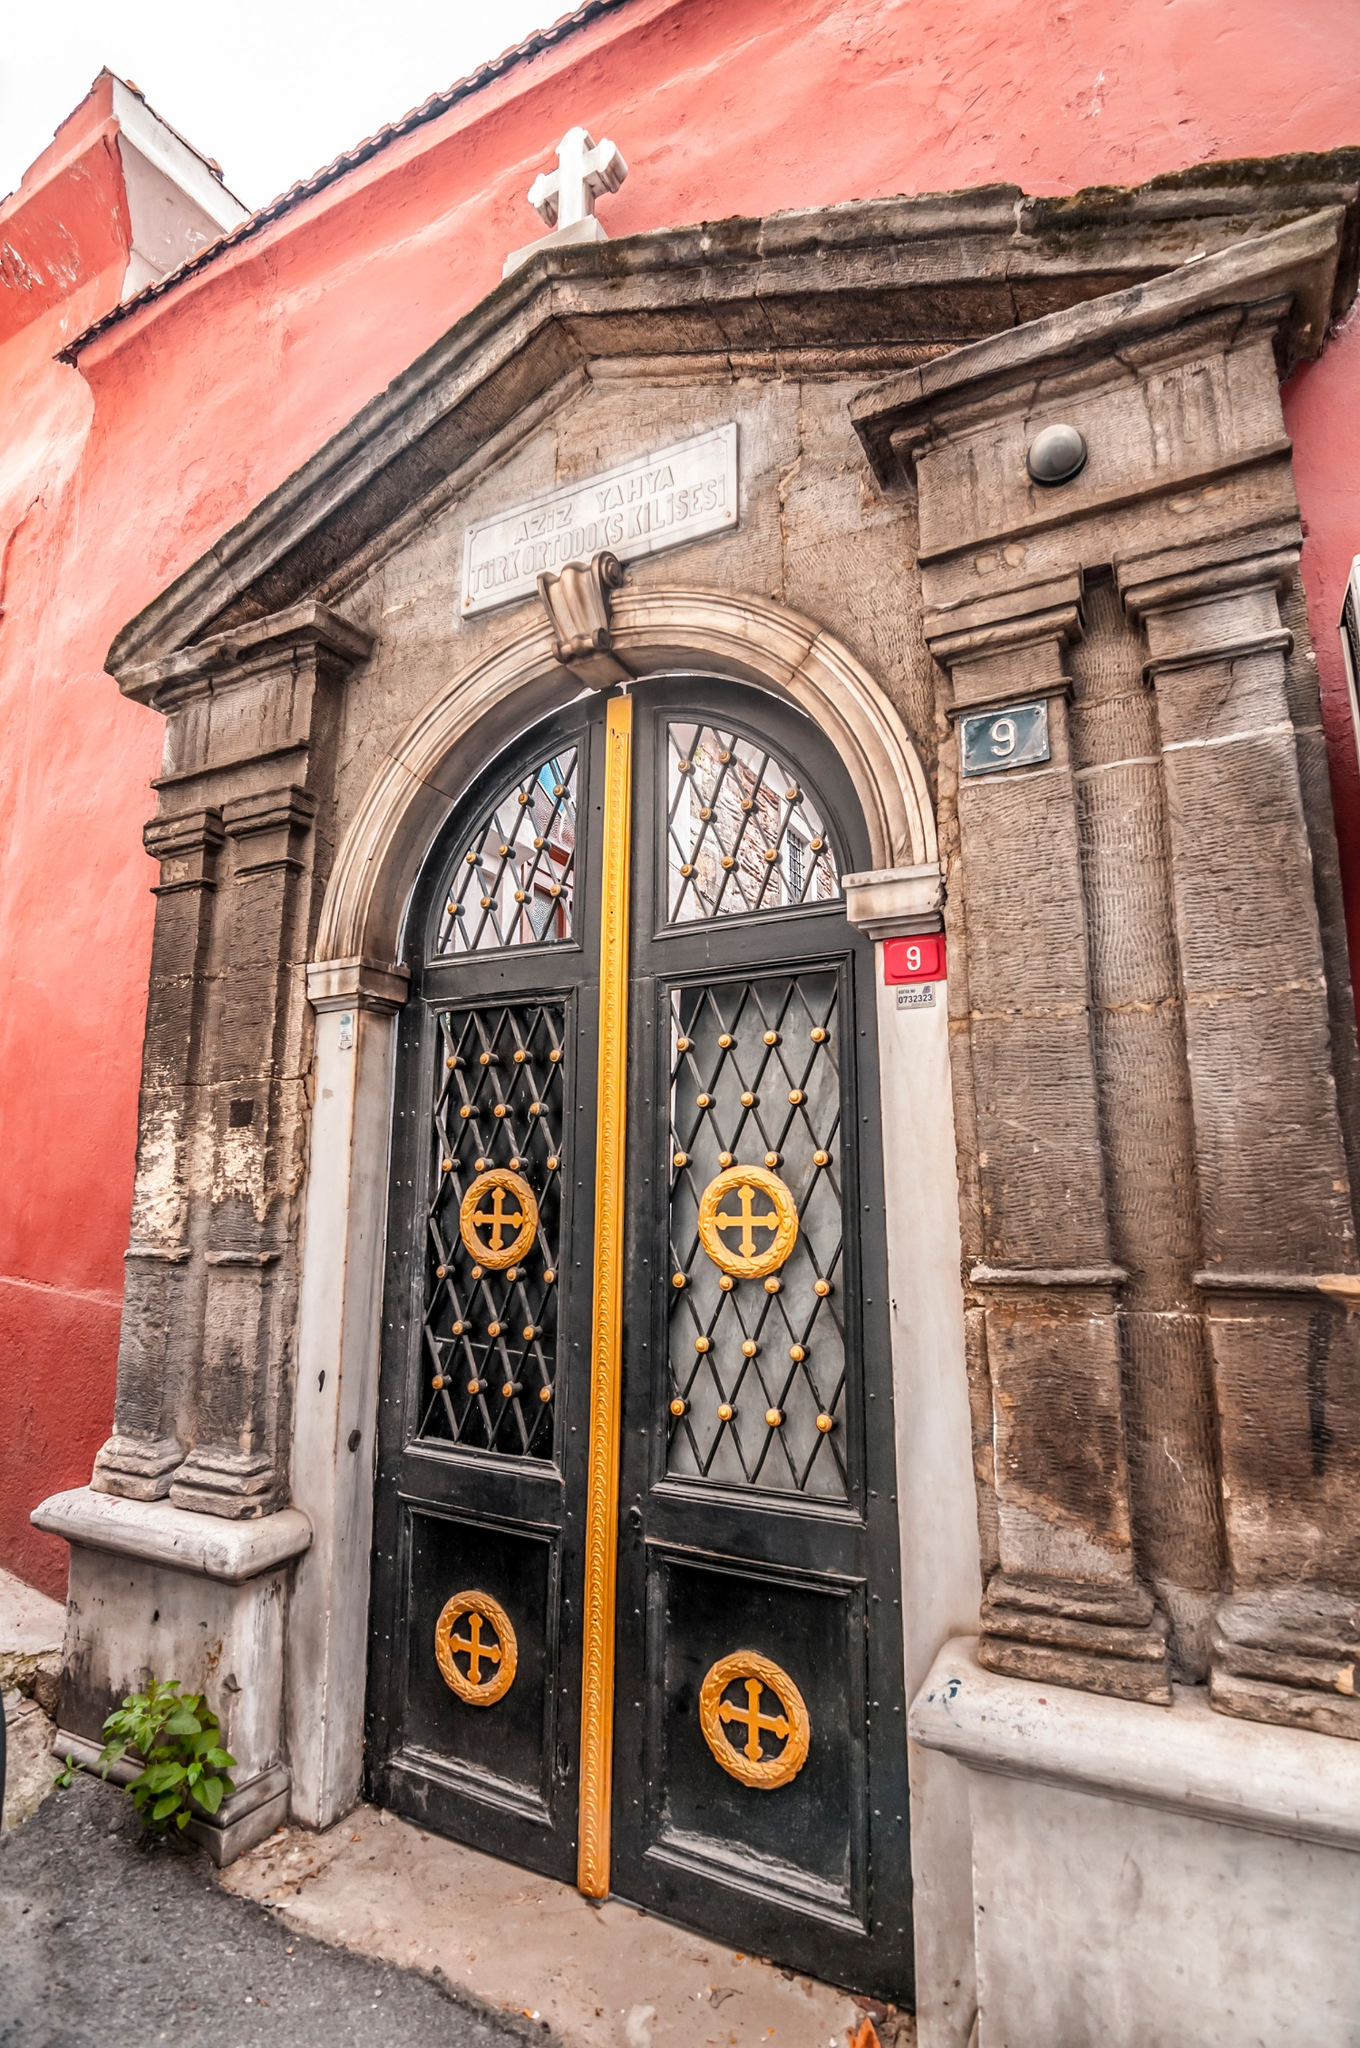Can you describe the significance of the architectural elements present in the image? The architectural elements in the image are highly significant and convey a deep sense of tradition and history. The stone columns flanking the door are reminiscent of classical architectural styles, which often symbolize strength and permanence. The arched door is adorned with intricate metalwork featuring gold crosses, highlighting the building’s religious function and artistry. The plaque above the door bearing Greek inscriptions indicates the building’s affiliation with the Greek Orthodox Church. These elements collectively suggest that the building is not only a place of worship but also a piece of historical architecture reflective of the community’s cultural heritage. 